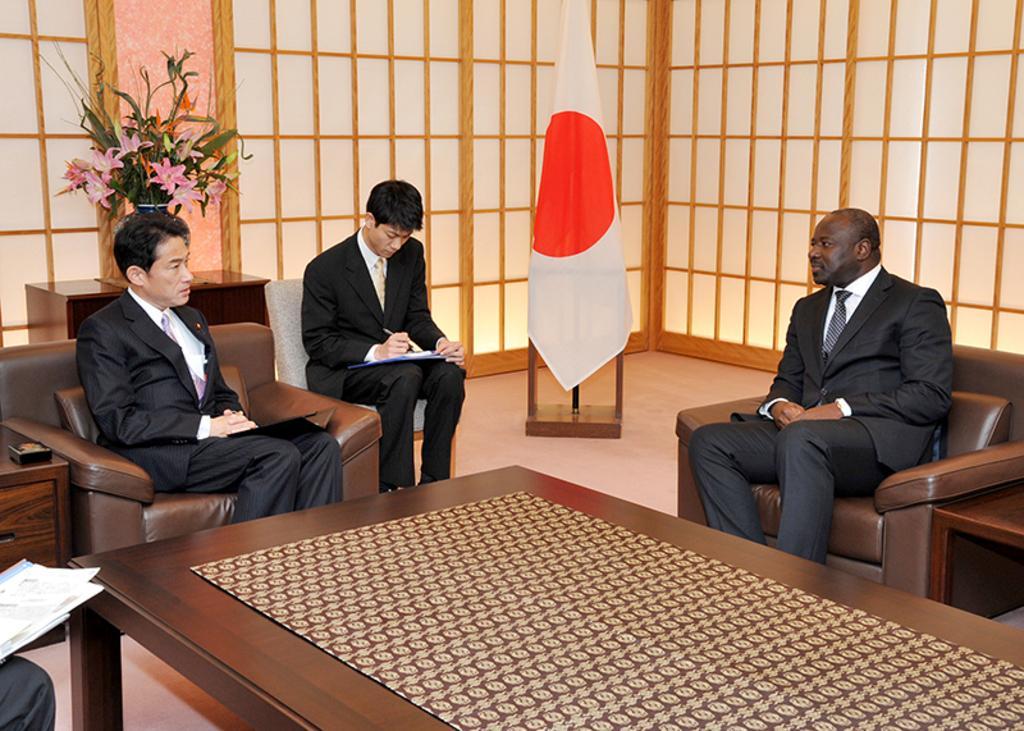Can you describe this image briefly? In this image I can see there are three people who are sitting on the chair wearing black suit, I can also see a flag, flower pot on the table. 